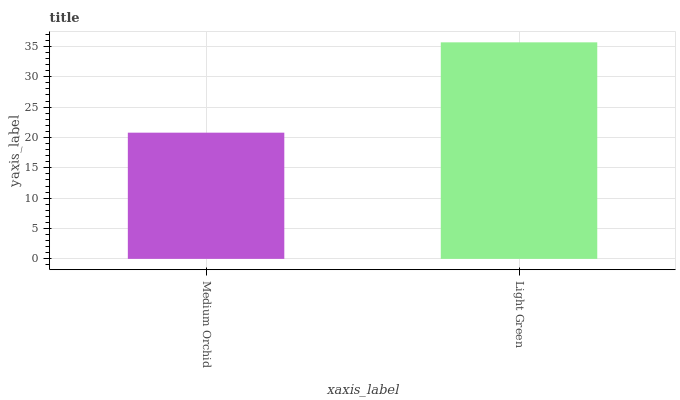Is Medium Orchid the minimum?
Answer yes or no. Yes. Is Light Green the maximum?
Answer yes or no. Yes. Is Light Green the minimum?
Answer yes or no. No. Is Light Green greater than Medium Orchid?
Answer yes or no. Yes. Is Medium Orchid less than Light Green?
Answer yes or no. Yes. Is Medium Orchid greater than Light Green?
Answer yes or no. No. Is Light Green less than Medium Orchid?
Answer yes or no. No. Is Light Green the high median?
Answer yes or no. Yes. Is Medium Orchid the low median?
Answer yes or no. Yes. Is Medium Orchid the high median?
Answer yes or no. No. Is Light Green the low median?
Answer yes or no. No. 